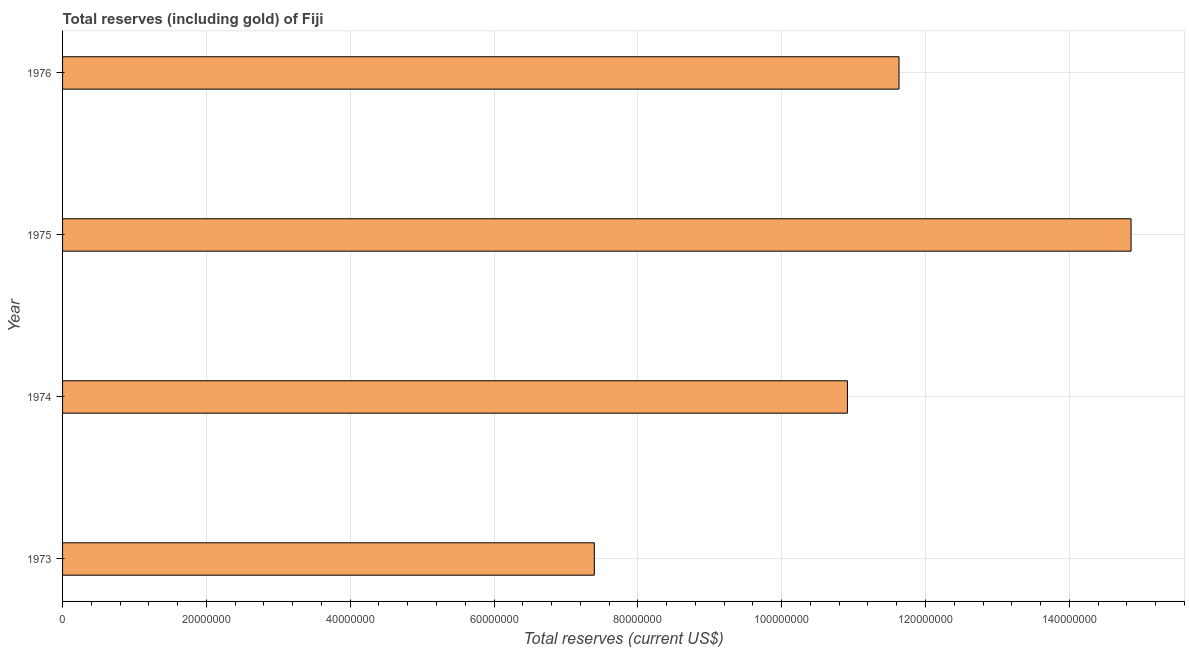Does the graph contain any zero values?
Offer a terse response. No. What is the title of the graph?
Your answer should be compact. Total reserves (including gold) of Fiji. What is the label or title of the X-axis?
Provide a succinct answer. Total reserves (current US$). What is the total reserves (including gold) in 1974?
Make the answer very short. 1.09e+08. Across all years, what is the maximum total reserves (including gold)?
Give a very brief answer. 1.49e+08. Across all years, what is the minimum total reserves (including gold)?
Provide a short and direct response. 7.39e+07. In which year was the total reserves (including gold) maximum?
Your response must be concise. 1975. What is the sum of the total reserves (including gold)?
Keep it short and to the point. 4.48e+08. What is the difference between the total reserves (including gold) in 1973 and 1974?
Make the answer very short. -3.52e+07. What is the average total reserves (including gold) per year?
Give a very brief answer. 1.12e+08. What is the median total reserves (including gold)?
Offer a terse response. 1.13e+08. What is the ratio of the total reserves (including gold) in 1974 to that in 1976?
Keep it short and to the point. 0.94. Is the total reserves (including gold) in 1973 less than that in 1975?
Make the answer very short. Yes. What is the difference between the highest and the second highest total reserves (including gold)?
Keep it short and to the point. 3.23e+07. Is the sum of the total reserves (including gold) in 1973 and 1974 greater than the maximum total reserves (including gold) across all years?
Your answer should be compact. Yes. What is the difference between the highest and the lowest total reserves (including gold)?
Provide a short and direct response. 7.46e+07. How many bars are there?
Your answer should be very brief. 4. Are all the bars in the graph horizontal?
Offer a very short reply. Yes. What is the Total reserves (current US$) of 1973?
Provide a succinct answer. 7.39e+07. What is the Total reserves (current US$) of 1974?
Your response must be concise. 1.09e+08. What is the Total reserves (current US$) in 1975?
Provide a short and direct response. 1.49e+08. What is the Total reserves (current US$) in 1976?
Offer a terse response. 1.16e+08. What is the difference between the Total reserves (current US$) in 1973 and 1974?
Give a very brief answer. -3.52e+07. What is the difference between the Total reserves (current US$) in 1973 and 1975?
Offer a terse response. -7.46e+07. What is the difference between the Total reserves (current US$) in 1973 and 1976?
Ensure brevity in your answer.  -4.24e+07. What is the difference between the Total reserves (current US$) in 1974 and 1975?
Provide a short and direct response. -3.94e+07. What is the difference between the Total reserves (current US$) in 1974 and 1976?
Your answer should be compact. -7.17e+06. What is the difference between the Total reserves (current US$) in 1975 and 1976?
Offer a terse response. 3.23e+07. What is the ratio of the Total reserves (current US$) in 1973 to that in 1974?
Provide a short and direct response. 0.68. What is the ratio of the Total reserves (current US$) in 1973 to that in 1975?
Your answer should be very brief. 0.5. What is the ratio of the Total reserves (current US$) in 1973 to that in 1976?
Provide a succinct answer. 0.64. What is the ratio of the Total reserves (current US$) in 1974 to that in 1975?
Keep it short and to the point. 0.73. What is the ratio of the Total reserves (current US$) in 1974 to that in 1976?
Your response must be concise. 0.94. What is the ratio of the Total reserves (current US$) in 1975 to that in 1976?
Keep it short and to the point. 1.28. 